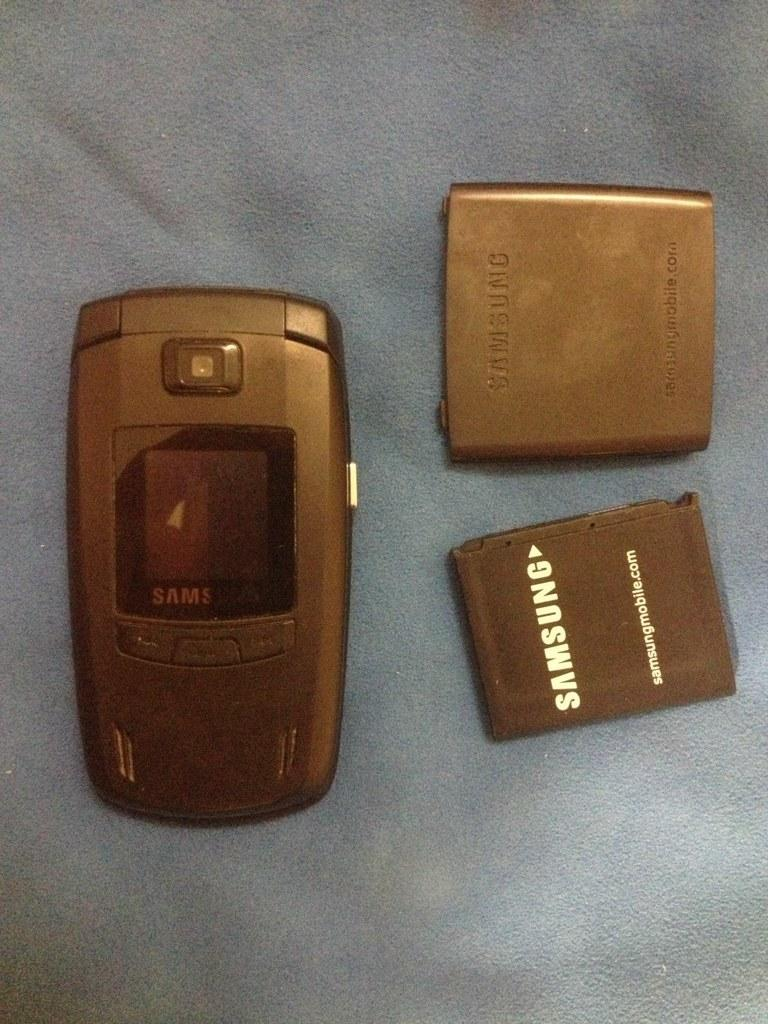<image>
Write a terse but informative summary of the picture. A battery has been removed from a Samsung phone and sits next to it on a blue surface. 